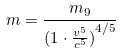Convert formula to latex. <formula><loc_0><loc_0><loc_500><loc_500>m = \frac { m _ { 9 } } { ( { 1 \cdot \frac { v ^ { 5 } } { c ^ { 5 } } ) } ^ { 4 / 5 } }</formula> 